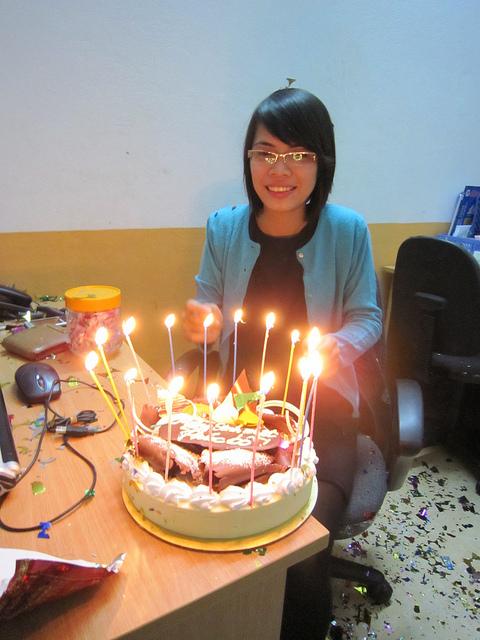What is the woman smiling at?
Concise answer only. Birthday cake. Where is the cake?
Be succinct. On desk. What is the top of this cake decorated with?
Give a very brief answer. Candles. How many candles are shown?
Quick response, please. 15. Is the lady going to blow the candles?
Short answer required. Yes. What is on the floor?
Concise answer only. Confetti. Is it dark in the room?
Write a very short answer. No. 